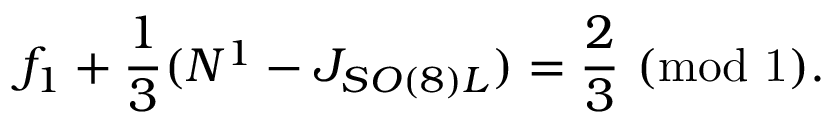Convert formula to latex. <formula><loc_0><loc_0><loc_500><loc_500>f _ { 1 } + { \frac { 1 } { 3 } } ( N ^ { 1 } - J _ { S O ( 8 ) L } ) = { \frac { 2 } { 3 } } ( m o d 1 ) .</formula> 